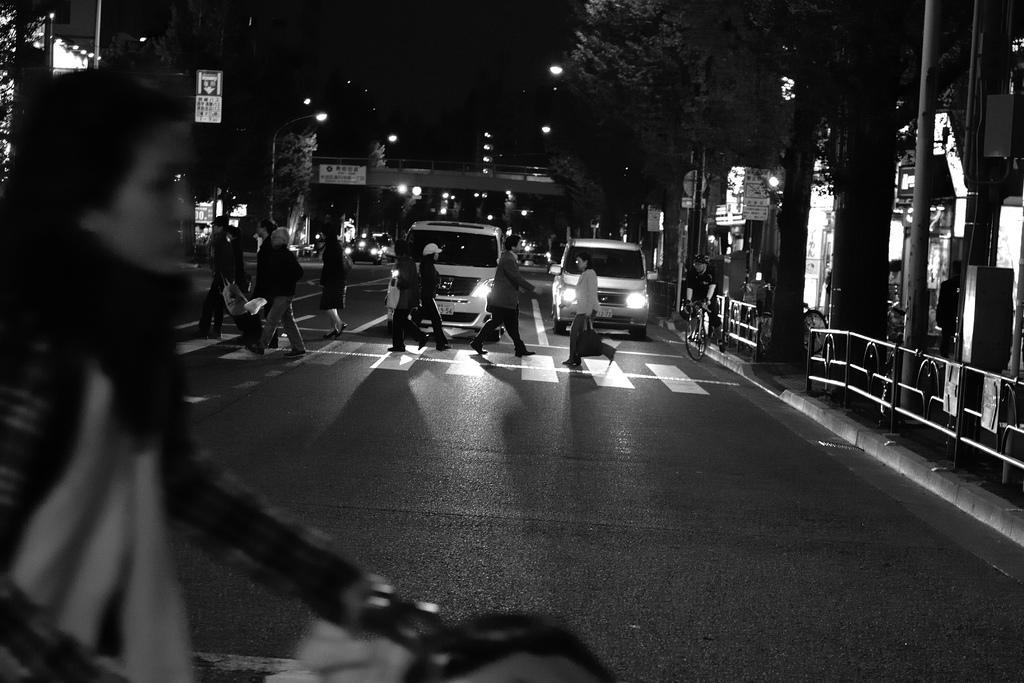Please provide a concise description of this image. In this picture there are a group of people crossing the road and their some vehicles in the backdrop 